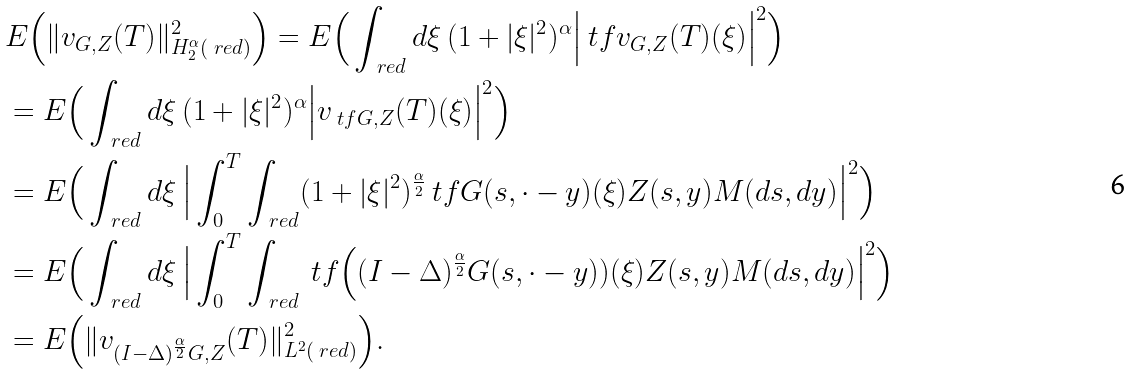Convert formula to latex. <formula><loc_0><loc_0><loc_500><loc_500>& E \Big ( \| v _ { G , Z } ( T ) \| ^ { 2 } _ { H _ { 2 } ^ { \alpha } ( \ r e d ) } \Big ) = E \Big ( \int _ { \ r e d } d \xi \, ( 1 + | \xi | ^ { 2 } ) ^ { \alpha } \Big | \ t f v _ { G , Z } ( T ) ( \xi ) \Big | ^ { 2 } \Big ) \\ & = E \Big ( \int _ { \ r e d } d \xi \, ( 1 + | \xi | ^ { 2 } ) ^ { \alpha } \Big | v _ { \ t f G , Z } ( T ) ( \xi ) \Big | ^ { 2 } \Big ) \\ & = E \Big ( \int _ { \ r e d } d \xi \, \Big | \int _ { 0 } ^ { T } \int _ { \ r e d } ( 1 + | \xi | ^ { 2 } ) ^ { \frac { \alpha } { 2 } } \ t f G ( s , \cdot - y ) ( \xi ) Z ( s , y ) M ( d s , d y ) \Big | ^ { 2 } \Big ) \\ & = E \Big ( \int _ { \ r e d } d \xi \, \Big | \int _ { 0 } ^ { T } \int _ { \ r e d } \ t f \Big ( ( I - \Delta ) ^ { \frac { \alpha } { 2 } } G ( s , \cdot - y ) ) ( \xi ) Z ( s , y ) M ( d s , d y ) \Big | ^ { 2 } \Big ) \\ & = E \Big ( \| v _ { ( I - \Delta ) ^ { \frac { \alpha } { 2 } } G , Z } ( T ) \| ^ { 2 } _ { L ^ { 2 } ( \ r e d ) } \Big ) .</formula> 